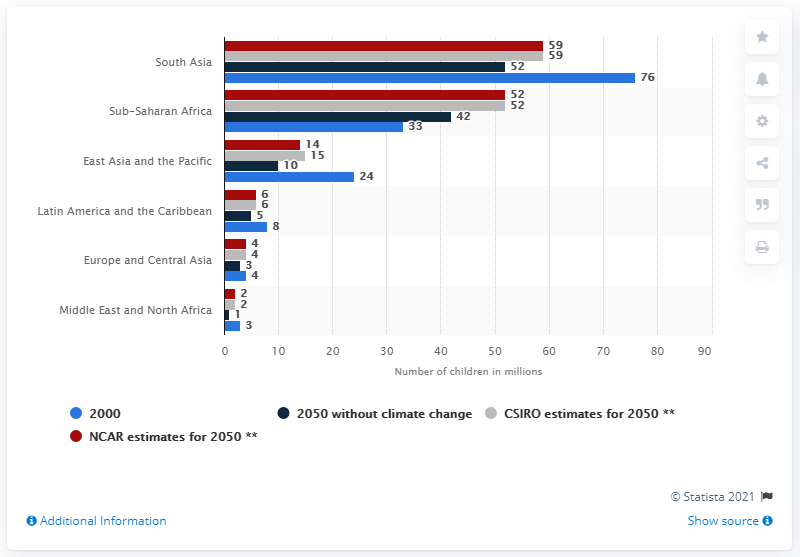List a handful of essential elements in this visual. In South Asia in 2000, a total of 76 malnourished children were registered. 